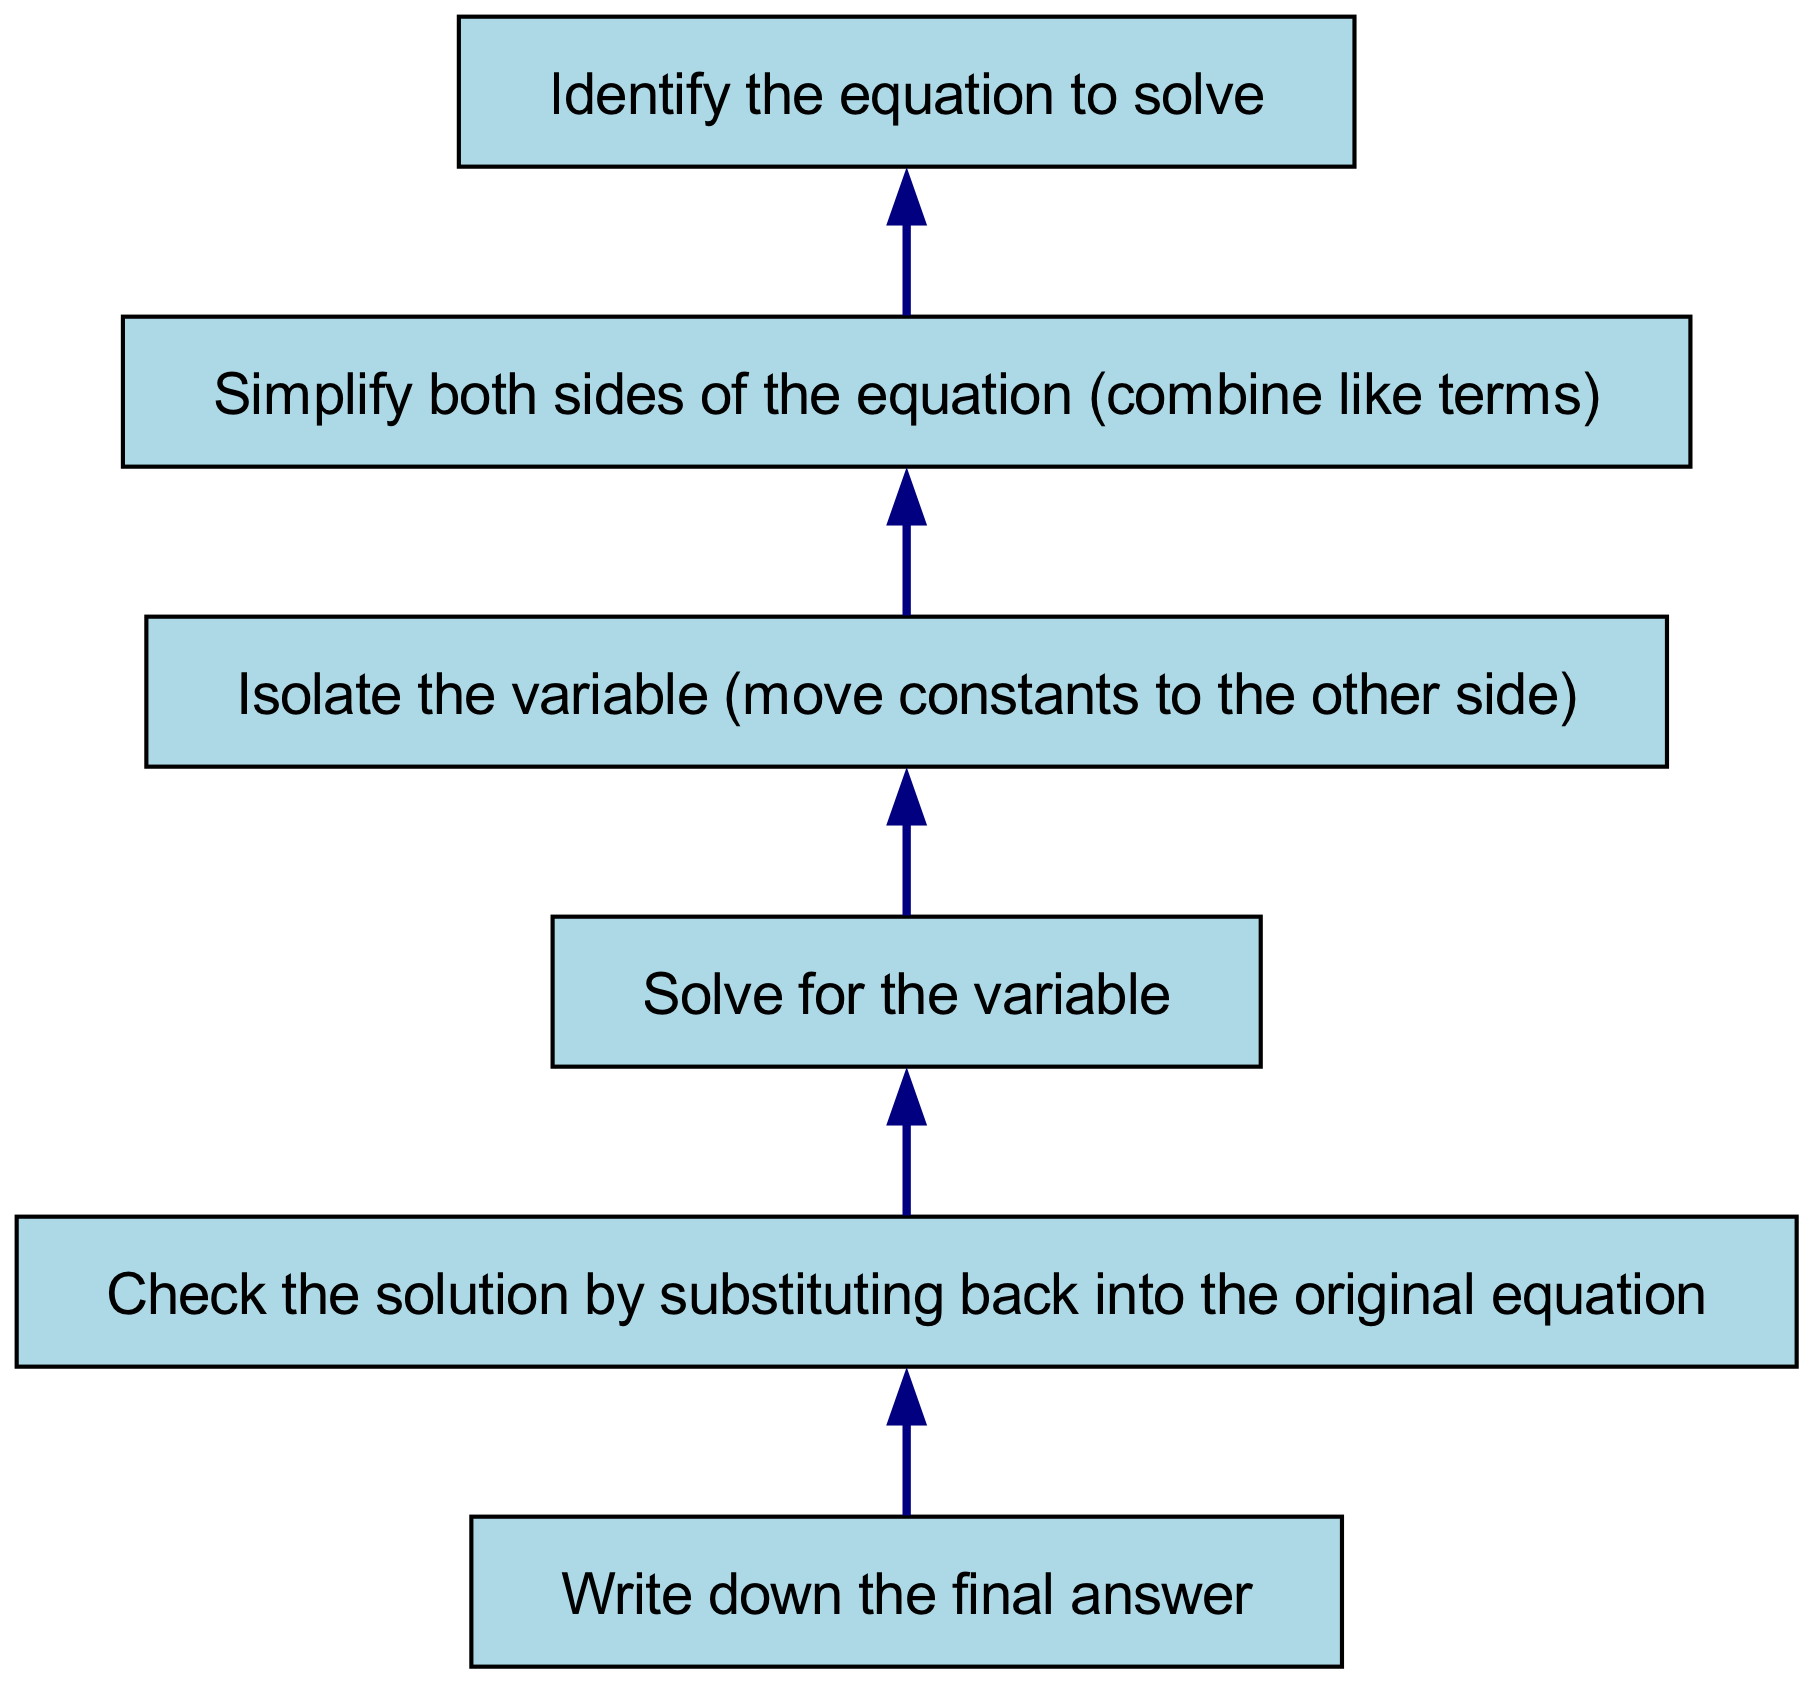What is the first step in solving the equation? The first step is to identify the equation to solve, which corresponds to the bottom node in the diagram.
Answer: Identify the equation to solve How many steps are there in the flow chart? Counting the nodes from bottom to top, there are a total of six steps in the flow chart.
Answer: Six What is the last step shown in the chart? The last step, which is at the top of the flow chart, is to write down the final answer.
Answer: Write down the final answer What step comes after isolating the variable? After isolating the variable, the next step is to solve for the variable. This follows the node connection in the diagram.
Answer: Solve for the variable Why is checking the solution necessary? Checking the solution is necessary to verify the correctness of the answer by substituting it back into the original equation. This step helps ensure that the solution meets the conditions set by the equation.
Answer: To verify correctness What is the relationship between simplifying both sides and isolating the variable? Simplifying both sides of the equation is a prerequisite step before isolating the variable, as it allows for easier manipulation of the equation when moving constants.
Answer: Prerequisite step What does the arrow direction indicate in this flow chart? The arrow direction indicates the sequence of steps, showing the order in which the tasks must be completed, starting from the bottom step and moving upwards.
Answer: Sequence of steps 